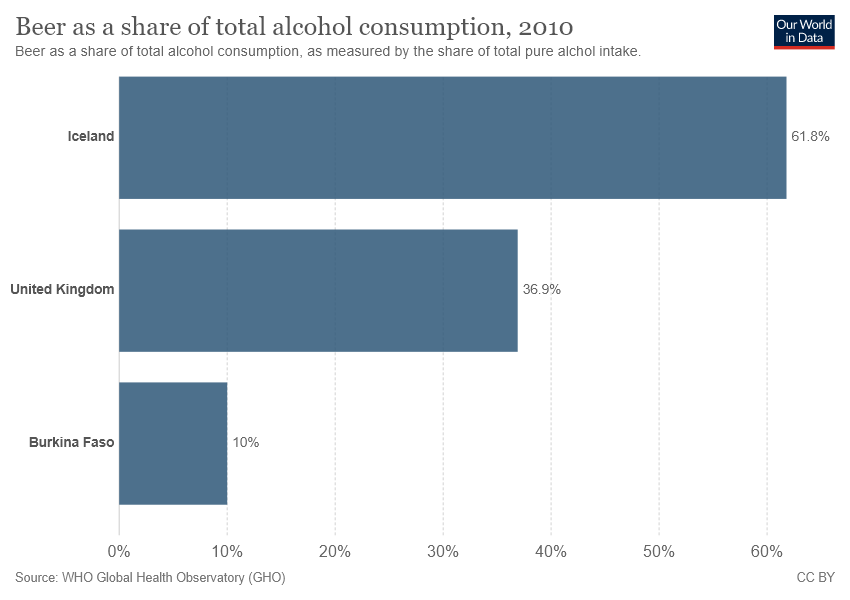Give some essential details in this illustration. The difference between the largest and smallest bar is greater than the smallest bar. The number of colors used in the graph is 1. 